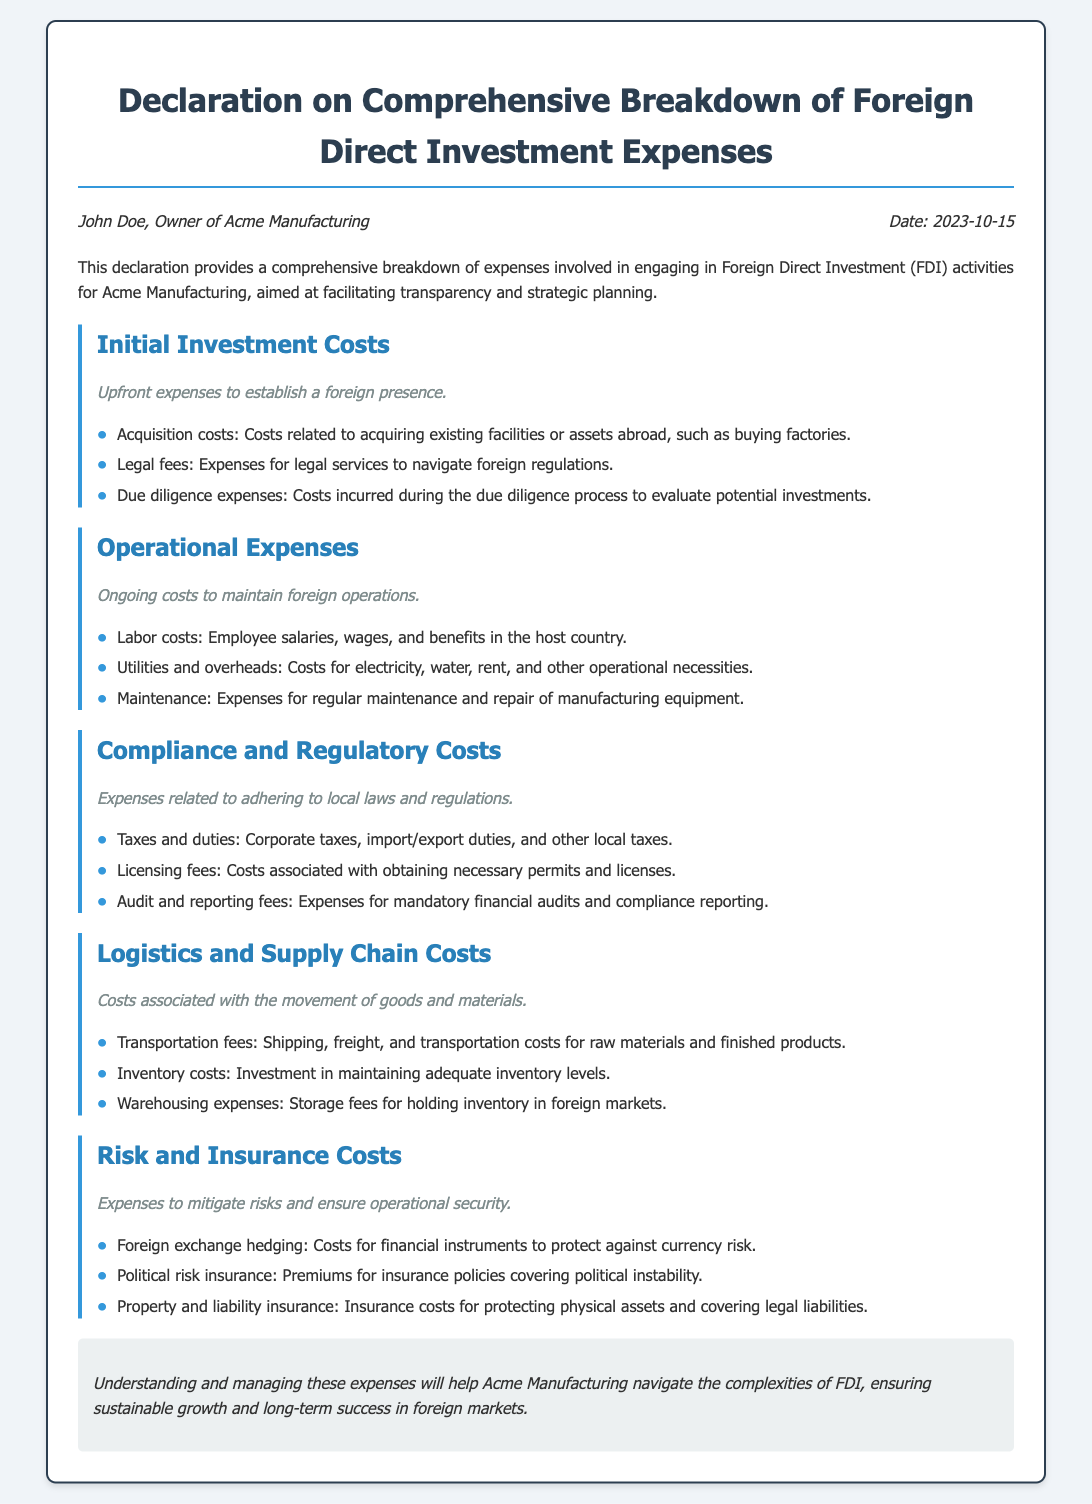What is the owner’s name? The owner of Acme Manufacturing, as stated in the document, is John Doe.
Answer: John Doe What date was the declaration made? The document indicates the declaration date as October 15, 2023.
Answer: 2023-10-15 What is meant by "initial investment costs"? This term refers to upfront expenses to establish a foreign presence, as defined in the document.
Answer: Upfront expenses List one example of operational expenses. The document provides several examples, including employee salaries, which fall under labor costs.
Answer: Labor costs What type of costs are related to adhering to local laws? The document categorizes these as compliance and regulatory costs.
Answer: Compliance and regulatory costs Which category includes "foreign exchange hedging"? This falls under the risk and insurance costs as outlined in the document.
Answer: Risk and insurance costs How many sections are in the declaration? The declaration has five main sections detailing different types of investment expenses.
Answer: Five What is the purpose of this declaration? The main purpose stated is to facilitate transparency and strategic planning for FDI activities.
Answer: Transparency and strategic planning What is illustrated by the term "due diligence expenses"? It represents costs incurred during the due diligence process to evaluate potential investments, as mentioned in the document.
Answer: Evaluation of potential investments 